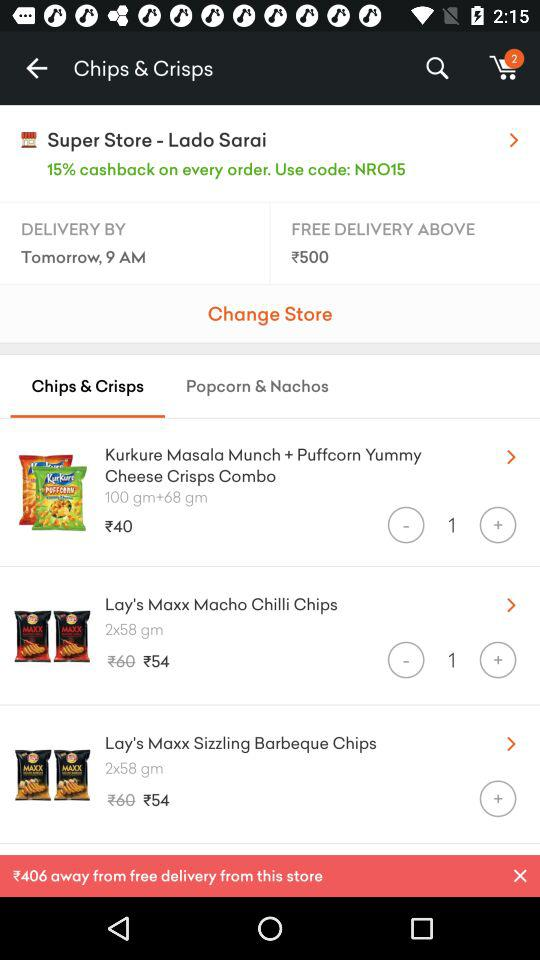What is the store location? The store location is Lado Sarai. 